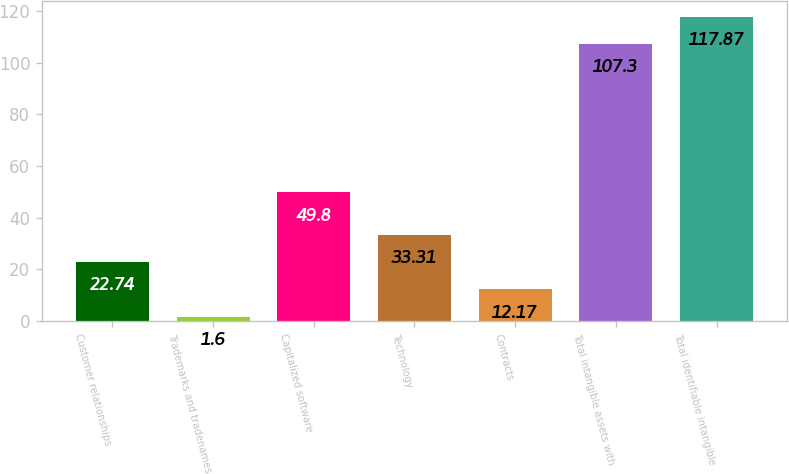Convert chart to OTSL. <chart><loc_0><loc_0><loc_500><loc_500><bar_chart><fcel>Customer relationships<fcel>Trademarks and tradenames<fcel>Capitalized software<fcel>Technology<fcel>Contracts<fcel>Total intangible assets with<fcel>Total identifiable intangible<nl><fcel>22.74<fcel>1.6<fcel>49.8<fcel>33.31<fcel>12.17<fcel>107.3<fcel>117.87<nl></chart> 